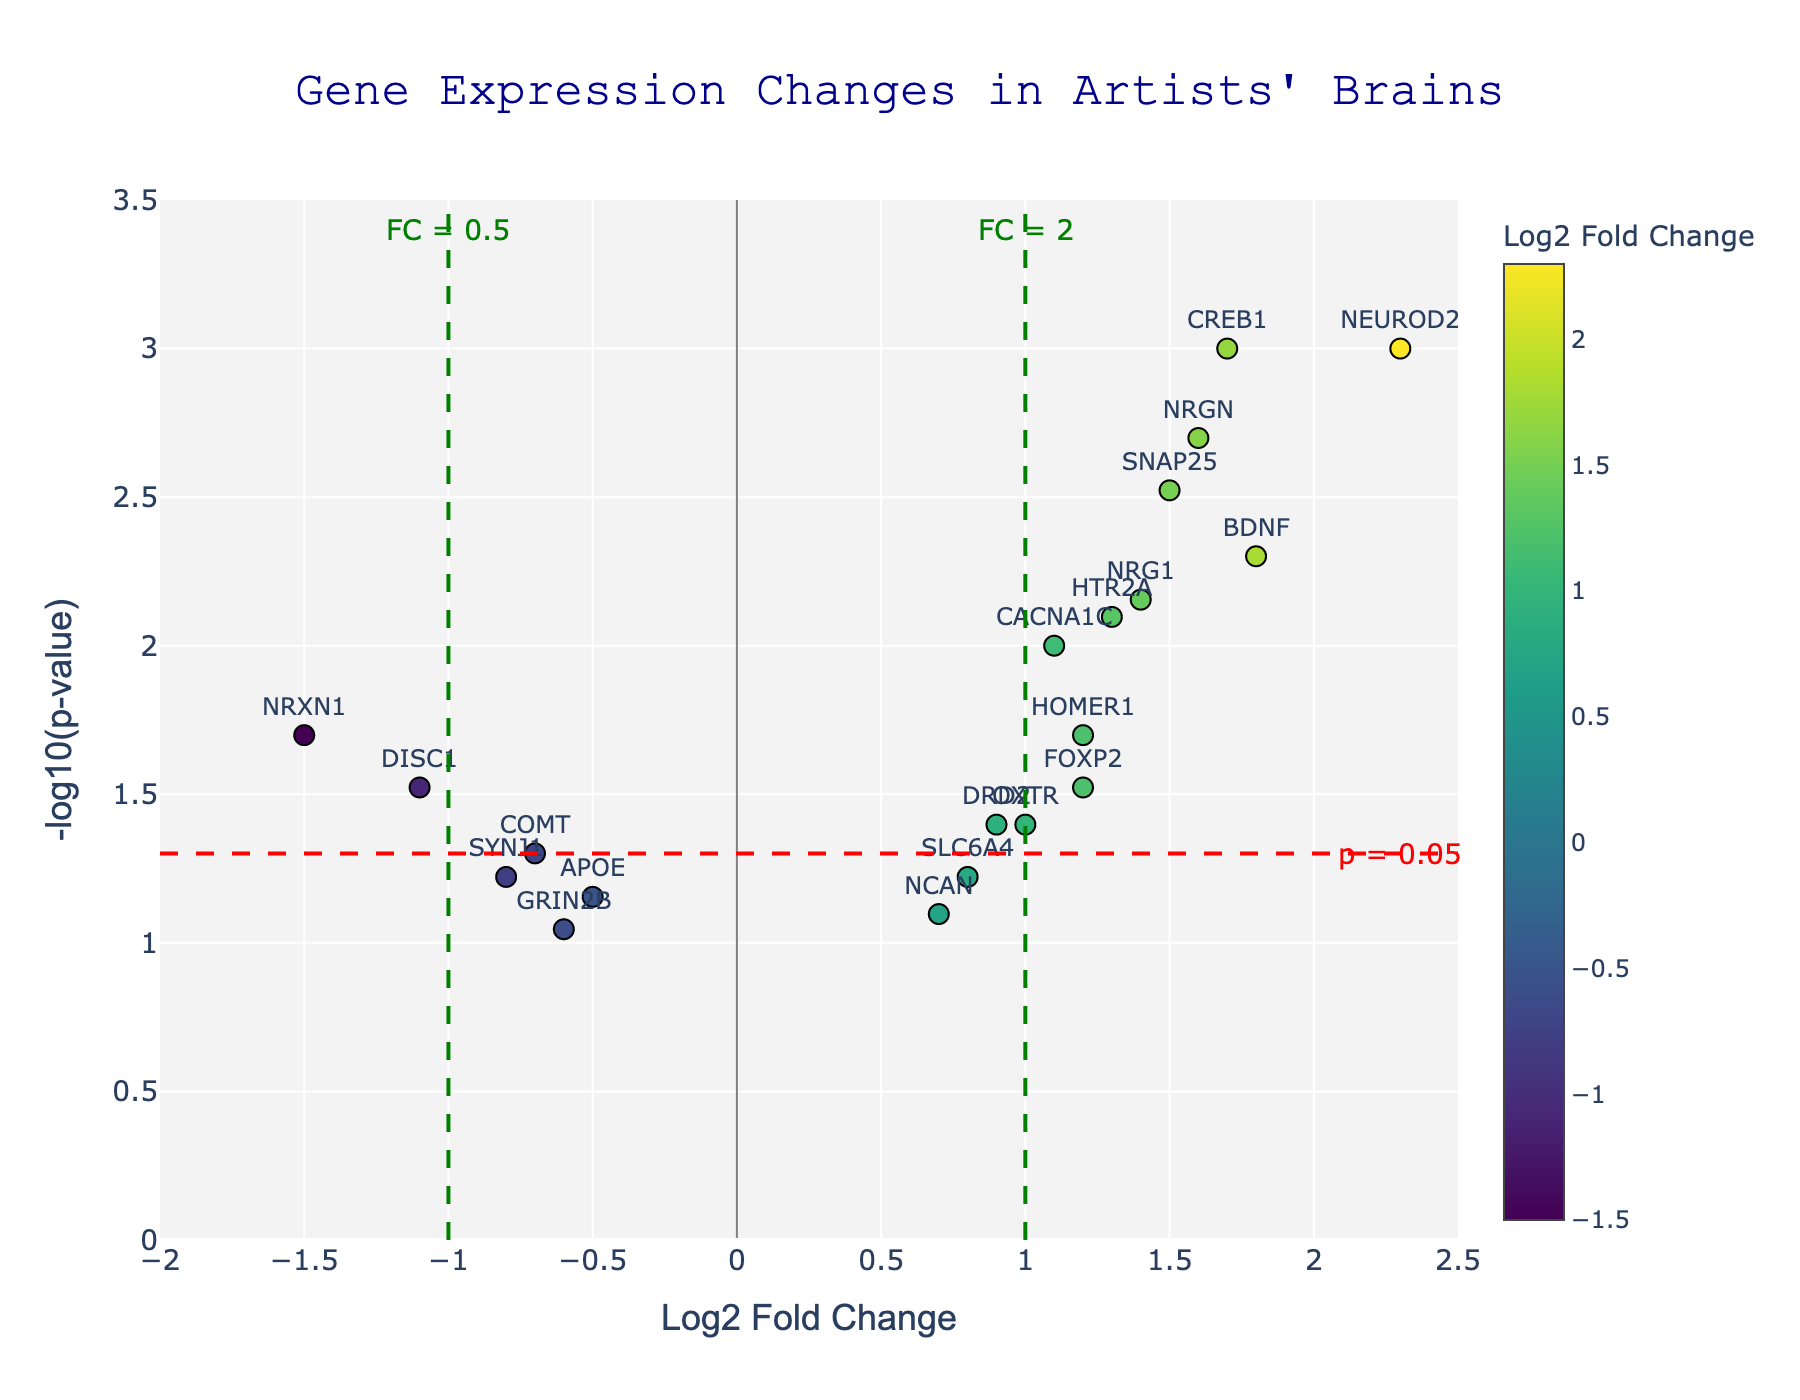What's the title of the figure? The title is usually displayed at the top of the figure, providing an overview of what the plot represents. In this plot, the title "Gene Expression Changes in Artists' Brains" is clearly mentioned.
Answer: Gene Expression Changes in Artists' Brains What is the x-axis labeling? The x-axis label describes the data represented along the horizontal axis. For this plot, the x-axis is labeled "Log2 Fold Change," indicating that it shows the logarithmic fold changes in gene expression.
Answer: Log2 Fold Change How many genes showed a positive Log2 Fold Change? To find the number of genes with positive Log2 Fold Change, count the data points to the right of the vertical line at x=0. The points with Log2 Fold Change greater than 0 are considered positive.
Answer: 12 Which gene has the highest Log2 Fold Change? Identify the point farthest to the right on the x-axis to find the gene with the highest Log2 Fold Change. The gene NEUROD2, marked at Log2 Fold Change of 2.3, has the highest value.
Answer: NEUROD2 Which gene has the lowest p-value? To determine the gene with the lowest p-value, look for the point at the highest position on the y-axis. The annotation shows CREB1 at the highest position, indicating it has the lowest p-value.
Answer: CREB1 What threshold lines are drawn on the Volano plot, and what do they represent? There are horizontal and vertical threshold lines. The horizontal red dashed line at y=-log10(0.05) represents the p-value threshold of 0.05. The vertical green dashed lines at x=±1 represent the Log2 Fold Change thresholds of ±1.
Answer: p = 0.05, FC = ±1 Which genes are considered significant based on both p-value and fold change thresholds? To be significant, genes should have a y-value above the -log10(0.05) line and be beyond ±1 on the x-axis. The genes meeting these criteria are NEUROD2, CREB1, and NRGN.
Answer: NEUROD2, CREB1, NRGN How many genes fall within the "not significant" region, both in p-value and fold change? Count the data points that lie below the horizontal red dashed line (p-value > 0.05) and between the two vertical green dashed lines (-1 < Log2 Fold Change < 1). These are genes not meeting significance criteria. There are 14 such genes.
Answer: 14 Compare the Log2 Fold Change values of genes NRG1 and DISC1. Which one shows higher expression change in artists' brains? Look for the positions of NRG1 and DISC1 on the x-axis. NRG1 is at Log2 Fold Change 1.4, while DISC1 is at -1.1. Since 1.4 > -1.1, NRG1 shows a higher expression change.
Answer: NRG1 Which genes have a p-value less than 0.01 and a positive Log2 Fold Change? Identify points above y=-log10(0.01) and to the right of x=0. The genes that meet this criteria are NEUROD2, CREB1, SNAP25, NRGN, NRG1, HTR2A, and CACNA1C.
Answer: NEUROD2, CREB1, SNAP25, NRGN, NRG1, HTR2A, CACNA1C 